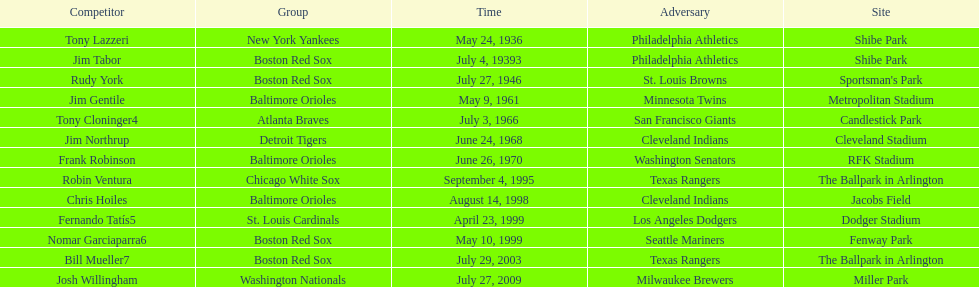What are the names of all the players? Tony Lazzeri, Jim Tabor, Rudy York, Jim Gentile, Tony Cloninger4, Jim Northrup, Frank Robinson, Robin Ventura, Chris Hoiles, Fernando Tatís5, Nomar Garciaparra6, Bill Mueller7, Josh Willingham. What are the names of all the teams holding home run records? New York Yankees, Boston Red Sox, Baltimore Orioles, Atlanta Braves, Detroit Tigers, Chicago White Sox, St. Louis Cardinals, Washington Nationals. Which player played for the new york yankees? Tony Lazzeri. 